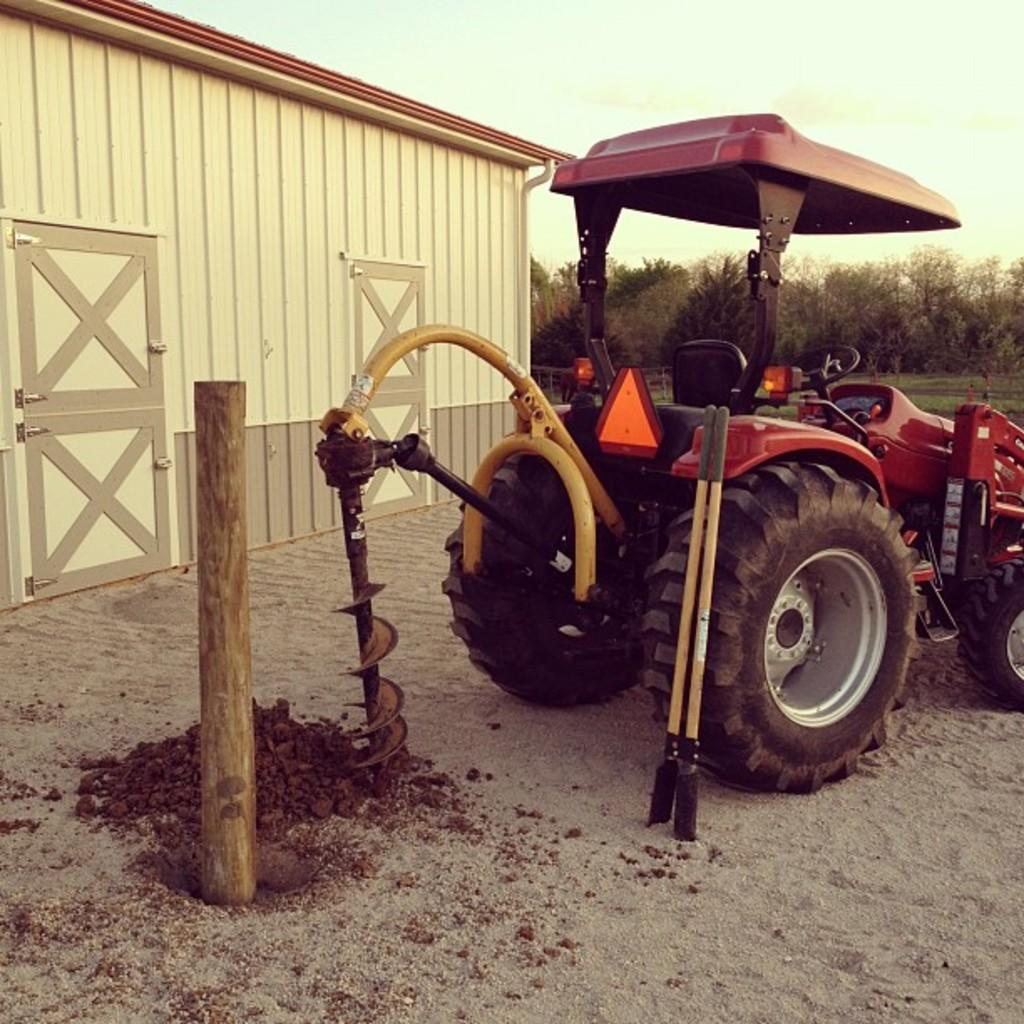What type of vehicle is in the image? The facts do not specify the type of vehicle, but there is a vehicle present in the image. What else can be seen in the image besides the vehicle? There is a pole, sand, a storage room, trees, and the sky visible in the image. What is the pole used for in the image? The facts do not specify the purpose of the pole, but it is present in the image. What type of terrain is visible in the image? There is sand visible in the image, suggesting a beach or desert setting. What is the storage room used for in the image? The facts do not specify the purpose of the storage room, but it is present in the image. What is the color of the sky in the image? The sky is visible in the image, but the facts do not specify its color. How many horses are visible in the image? There are no horses present in the image. What type of dirt can be seen on the ground in the image? The facts do not mention any dirt in the image, only sand is mentioned. 